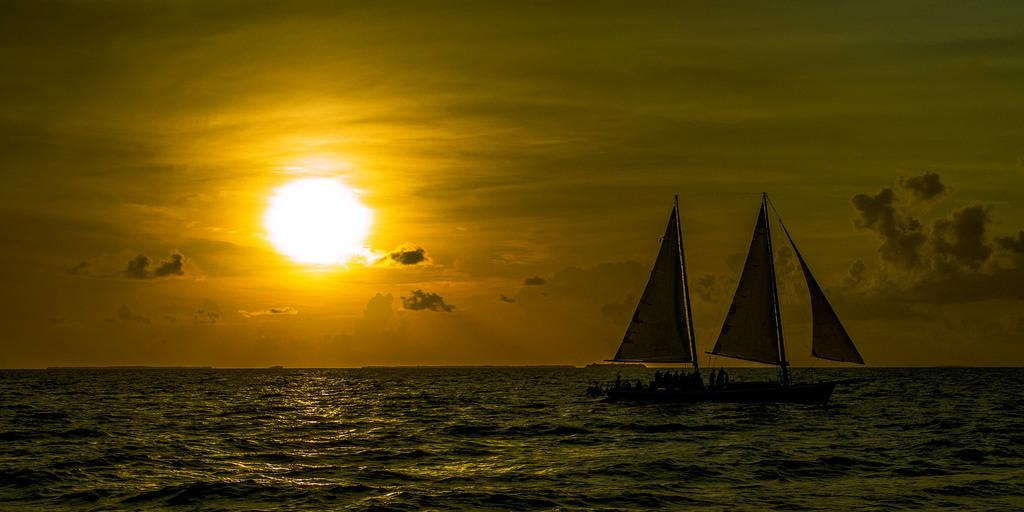What is located on the left side of the image? There is a sun on the left side of the image. What can be seen in the image besides the sun? There is water in the image, and two ships are moving in the water on the right side of the image. Where is the door located in the image? There is no door present in the image. Can you see a cow in the image? There is no cow present in the image. 